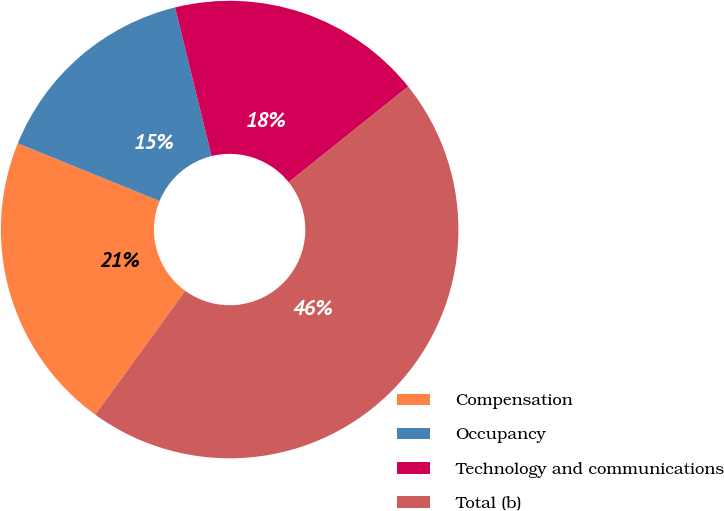Convert chart. <chart><loc_0><loc_0><loc_500><loc_500><pie_chart><fcel>Compensation<fcel>Occupancy<fcel>Technology and communications<fcel>Total (b)<nl><fcel>21.16%<fcel>15.01%<fcel>18.09%<fcel>45.74%<nl></chart> 